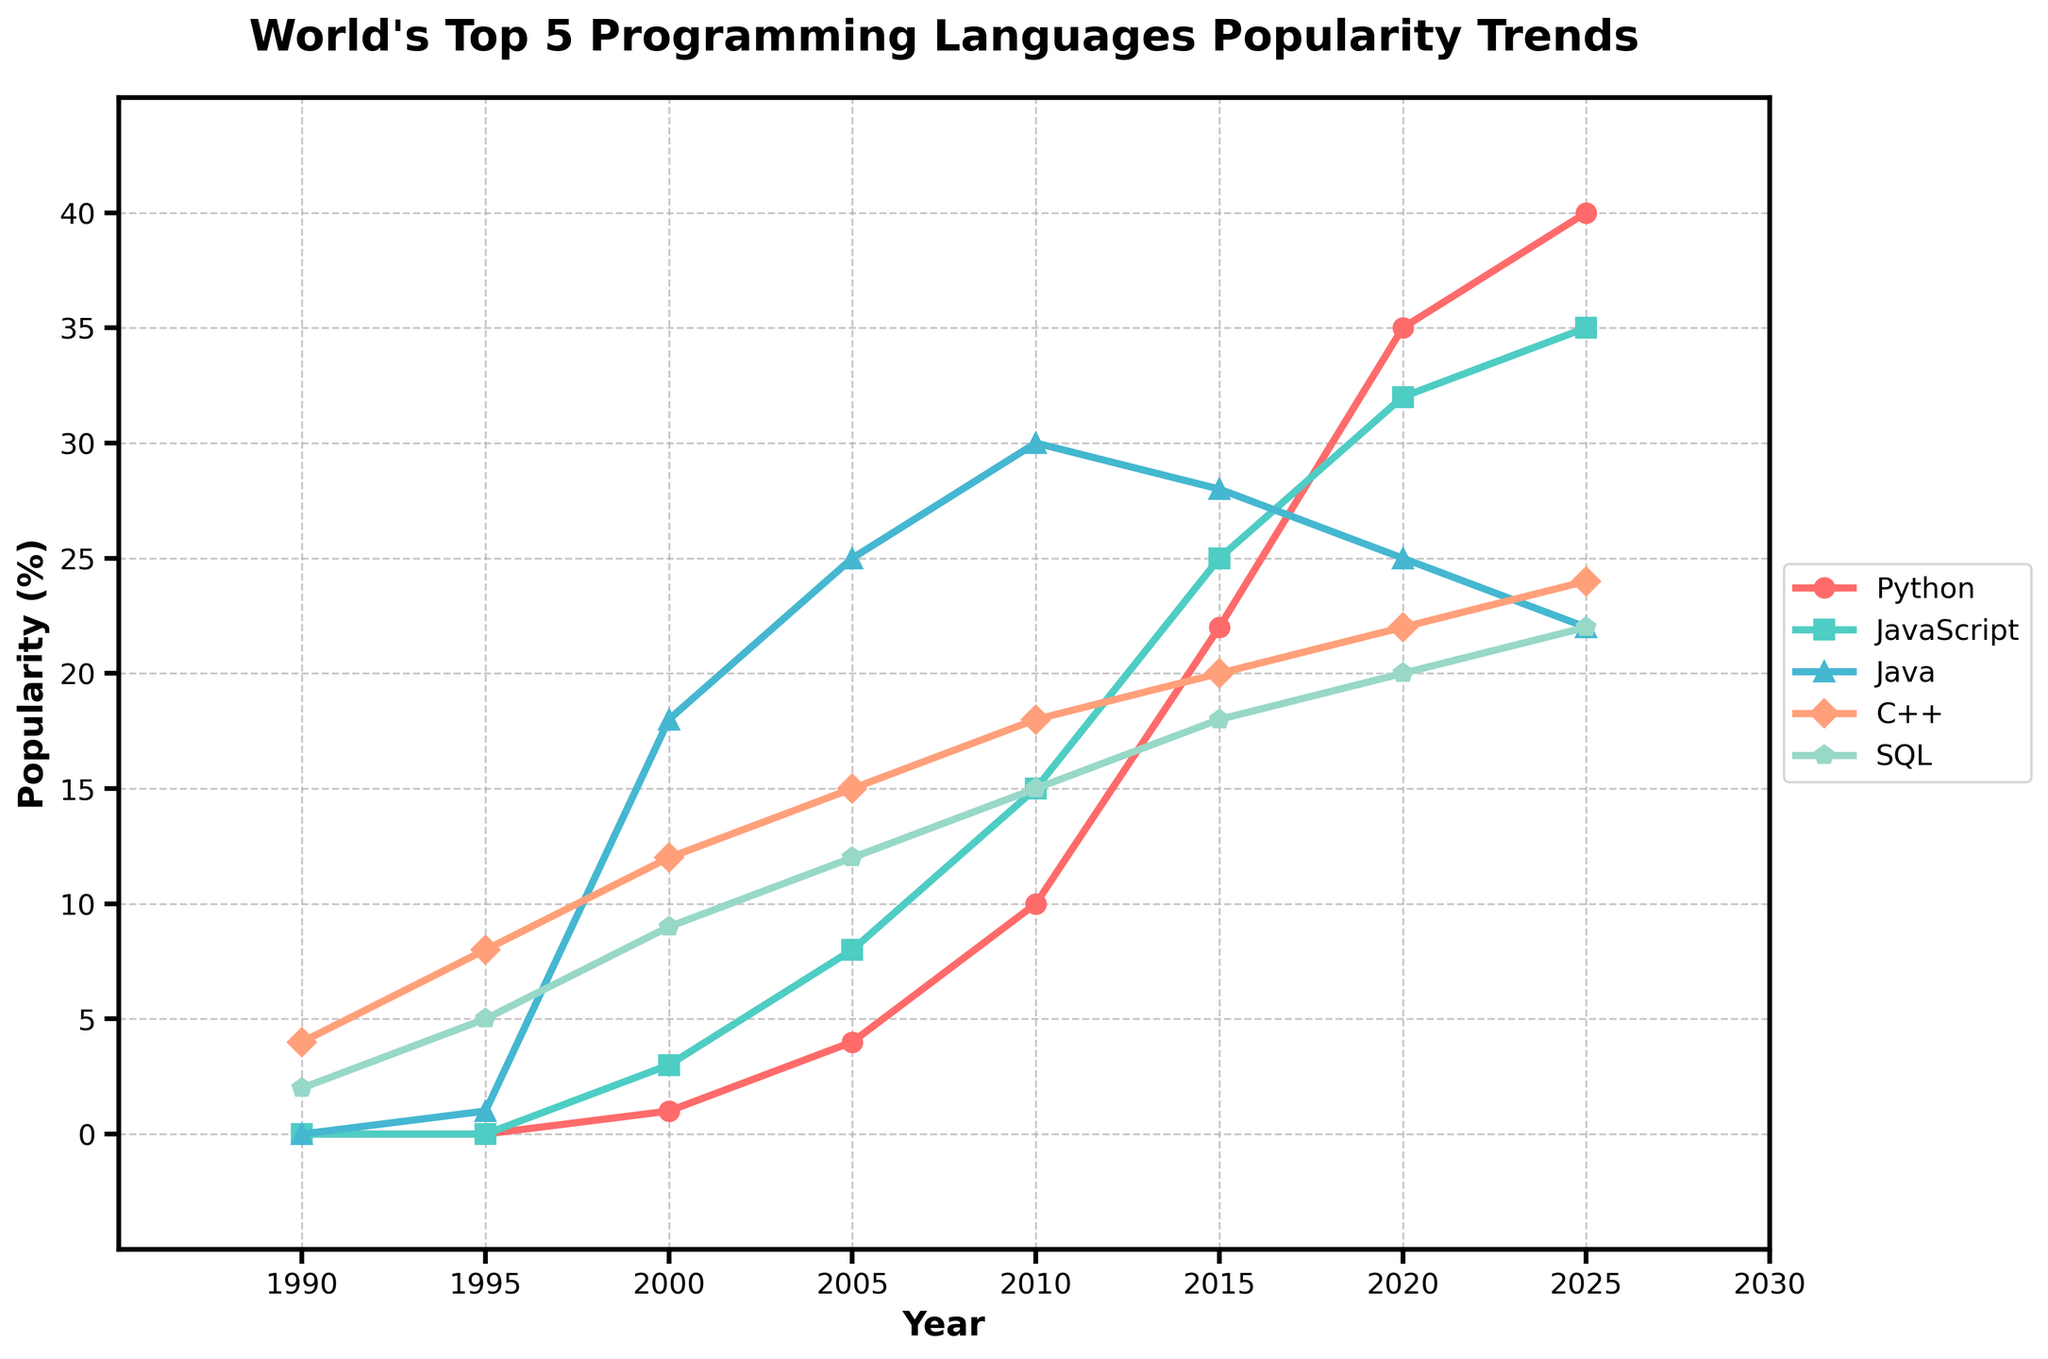What year did Python first appear in the chart? Look for the first non-zero value in the Python line. The year corresponding to Python's first non-zero value is 2000.
Answer: 2000 Which programming language showed the most significant increase in popularity from 1995 to 2000? Compare the increase in popularity for each language between these two years. Python increased by 1, JavaScript by 3, Java by 17, C++ by 4, and SQL by 4. Java had the most significant increase.
Answer: Java Between 2010 and 2020, which language's popularity trend was decreasing while others increased? Observe the trend of each language between 2010 and 2020. Only Java's popularity decreased from 30 to 25, while others increased or remained steady.
Answer: Java What is the average popularity of Python from 1990 to 2025? Sum Python's popularity percentages from all provided years (0 + 0 + 1 + 4 + 10 + 22 + 35 + 40) and divide by the number of years (7).
Answer: 14 In which year did JavaScript overtake Java in popularity? Identify the year where the JavaScript line crosses above the Java line. JavaScript overtakes Java between 2010 and 2015 and remains higher in subsequent years.
Answer: 2015 Which language had the highest initial popularity in 1990? Refer to the year 1990, C++ had the highest popularity with a value of 4.
Answer: C++ From 2015 to 2025, which two languages had the closest popularity percentages? Compare the percentages of each language at both points. SQL and C++ have values of 18 and 20 in 2015 and 22 and 24 in 2025, showing very close percentages.
Answer: SQL and C++ If you sum the popularity percentages of Python and JavaScript in 2020, does it exceed Java's popularity in 2005? Add the percentages of Python (35) and JavaScript (32) in 2020, which equals 67. Compare this to Java's 2005 popularity (25). 67 is greater than 25.
Answer: Yes Describe the trend of C++ from 1990 to 2025. C++ starts with a popularity of 4 in 1990 and generally increases over time, reaching 24 in 2025. The trend shows a steady increase.
Answer: Steady increase 